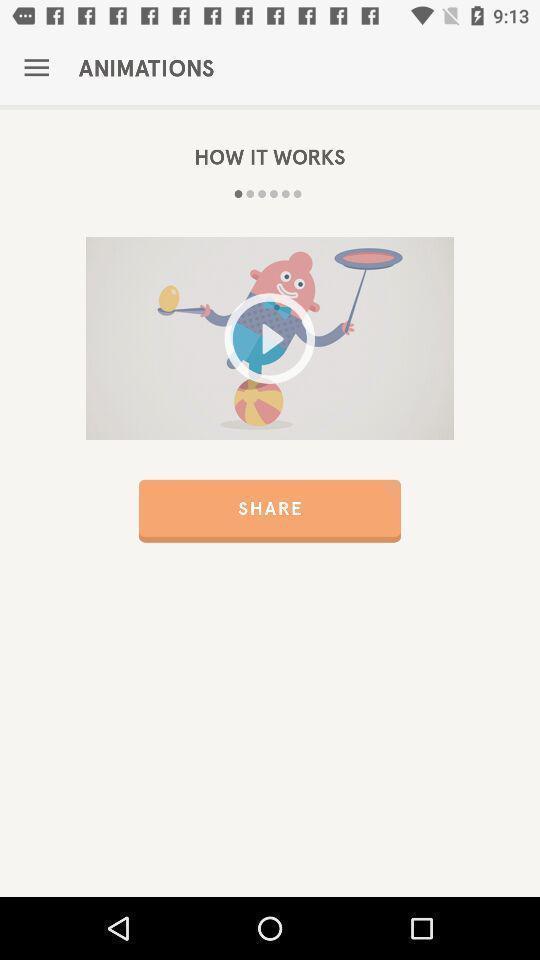Describe the visual elements of this screenshot. Window displaying an app guide to health. 